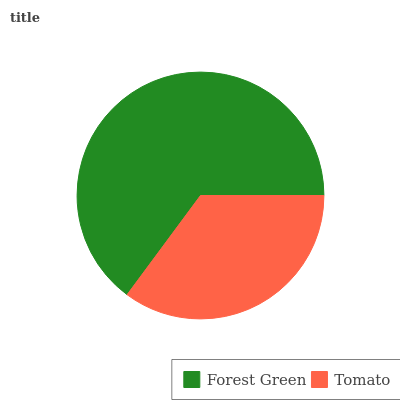Is Tomato the minimum?
Answer yes or no. Yes. Is Forest Green the maximum?
Answer yes or no. Yes. Is Tomato the maximum?
Answer yes or no. No. Is Forest Green greater than Tomato?
Answer yes or no. Yes. Is Tomato less than Forest Green?
Answer yes or no. Yes. Is Tomato greater than Forest Green?
Answer yes or no. No. Is Forest Green less than Tomato?
Answer yes or no. No. Is Forest Green the high median?
Answer yes or no. Yes. Is Tomato the low median?
Answer yes or no. Yes. Is Tomato the high median?
Answer yes or no. No. Is Forest Green the low median?
Answer yes or no. No. 